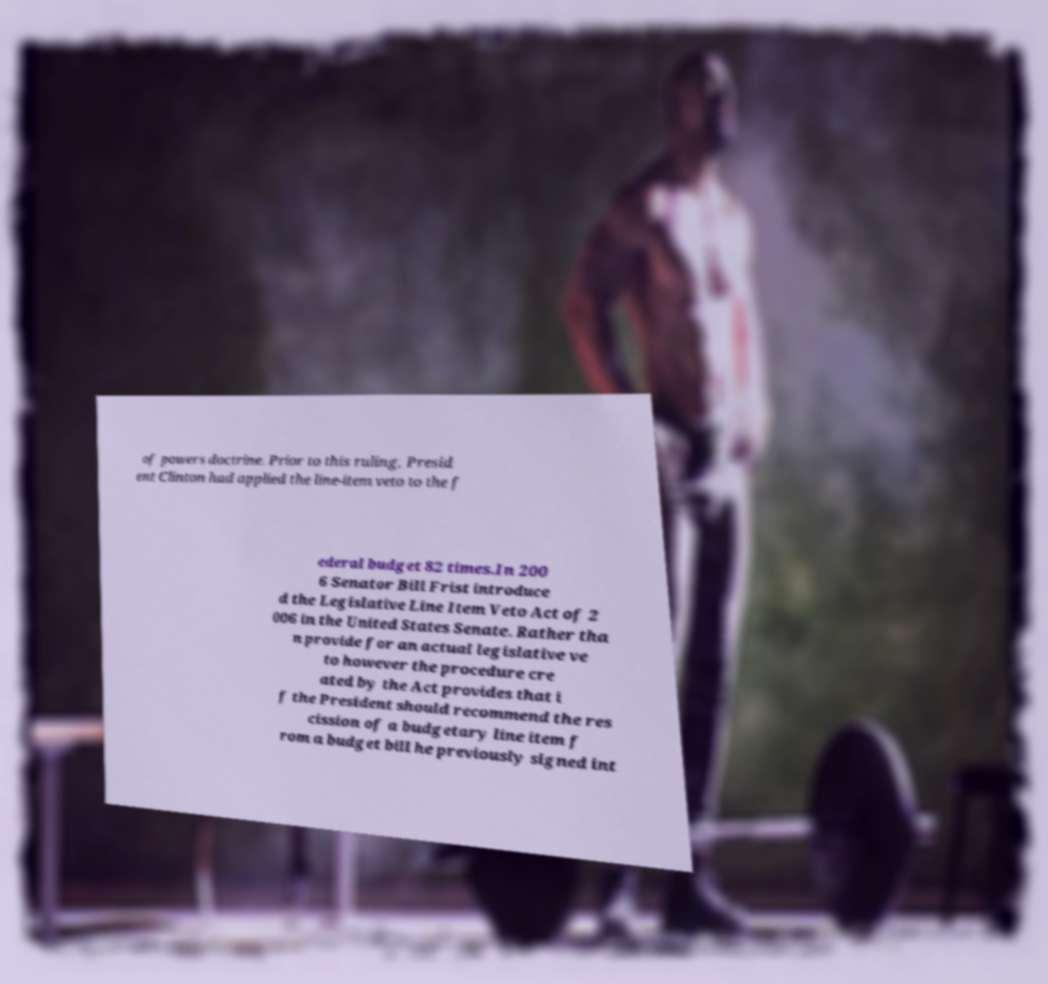What messages or text are displayed in this image? I need them in a readable, typed format. of powers doctrine. Prior to this ruling, Presid ent Clinton had applied the line-item veto to the f ederal budget 82 times.In 200 6 Senator Bill Frist introduce d the Legislative Line Item Veto Act of 2 006 in the United States Senate. Rather tha n provide for an actual legislative ve to however the procedure cre ated by the Act provides that i f the President should recommend the res cission of a budgetary line item f rom a budget bill he previously signed int 